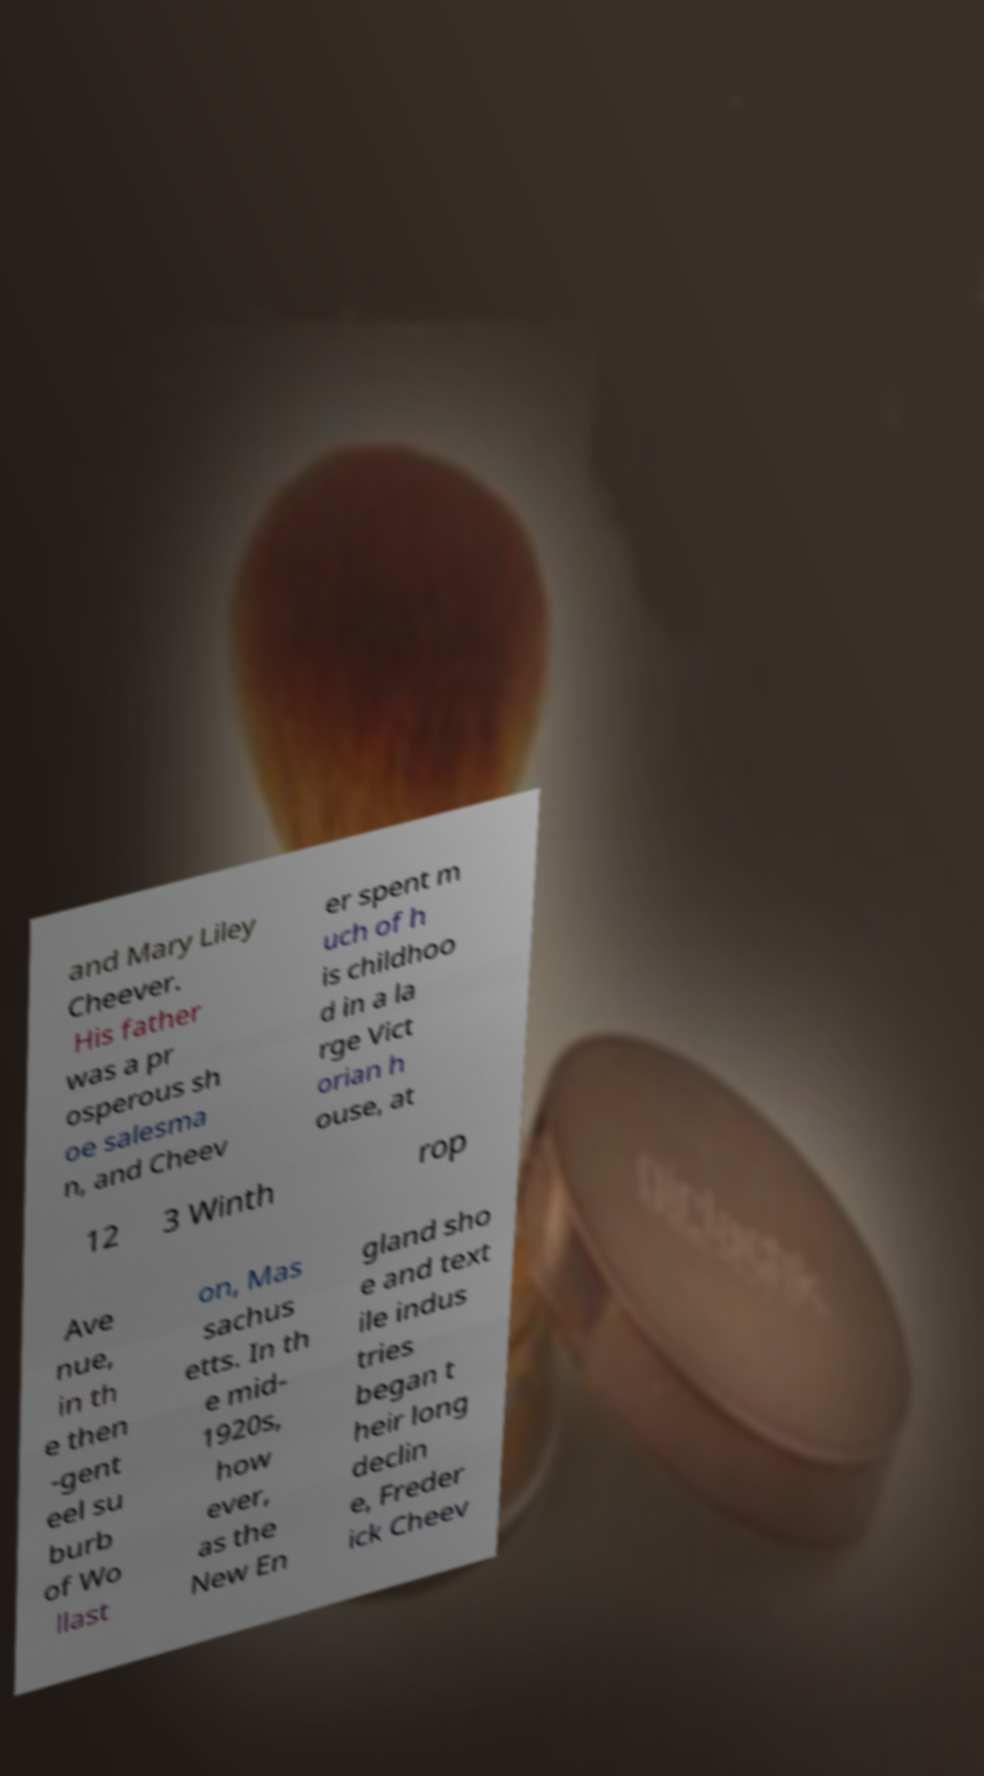Could you assist in decoding the text presented in this image and type it out clearly? and Mary Liley Cheever. His father was a pr osperous sh oe salesma n, and Cheev er spent m uch of h is childhoo d in a la rge Vict orian h ouse, at 12 3 Winth rop Ave nue, in th e then -gent eel su burb of Wo llast on, Mas sachus etts. In th e mid- 1920s, how ever, as the New En gland sho e and text ile indus tries began t heir long declin e, Freder ick Cheev 